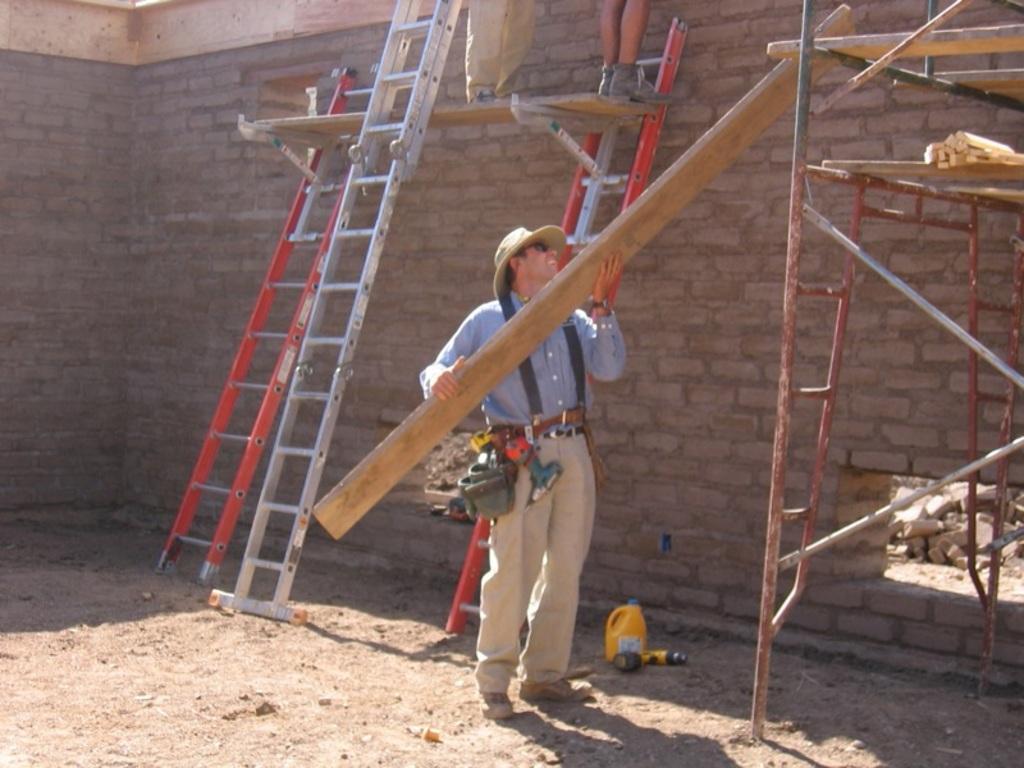Can you describe this image briefly? In this image there is a man holding wooden strip and there is a iron ladder, in the background there is a brick wall, to that brick wall there are three ladders, on that ladder two men standing,on the land there is a bottle. 